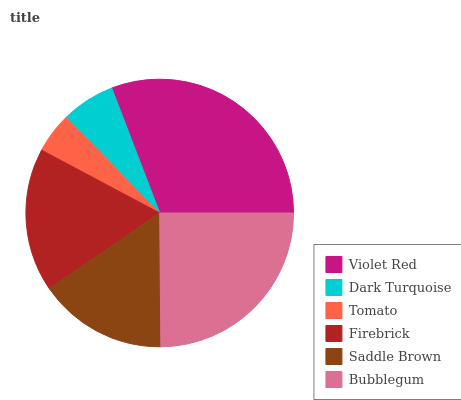Is Tomato the minimum?
Answer yes or no. Yes. Is Violet Red the maximum?
Answer yes or no. Yes. Is Dark Turquoise the minimum?
Answer yes or no. No. Is Dark Turquoise the maximum?
Answer yes or no. No. Is Violet Red greater than Dark Turquoise?
Answer yes or no. Yes. Is Dark Turquoise less than Violet Red?
Answer yes or no. Yes. Is Dark Turquoise greater than Violet Red?
Answer yes or no. No. Is Violet Red less than Dark Turquoise?
Answer yes or no. No. Is Firebrick the high median?
Answer yes or no. Yes. Is Saddle Brown the low median?
Answer yes or no. Yes. Is Violet Red the high median?
Answer yes or no. No. Is Tomato the low median?
Answer yes or no. No. 